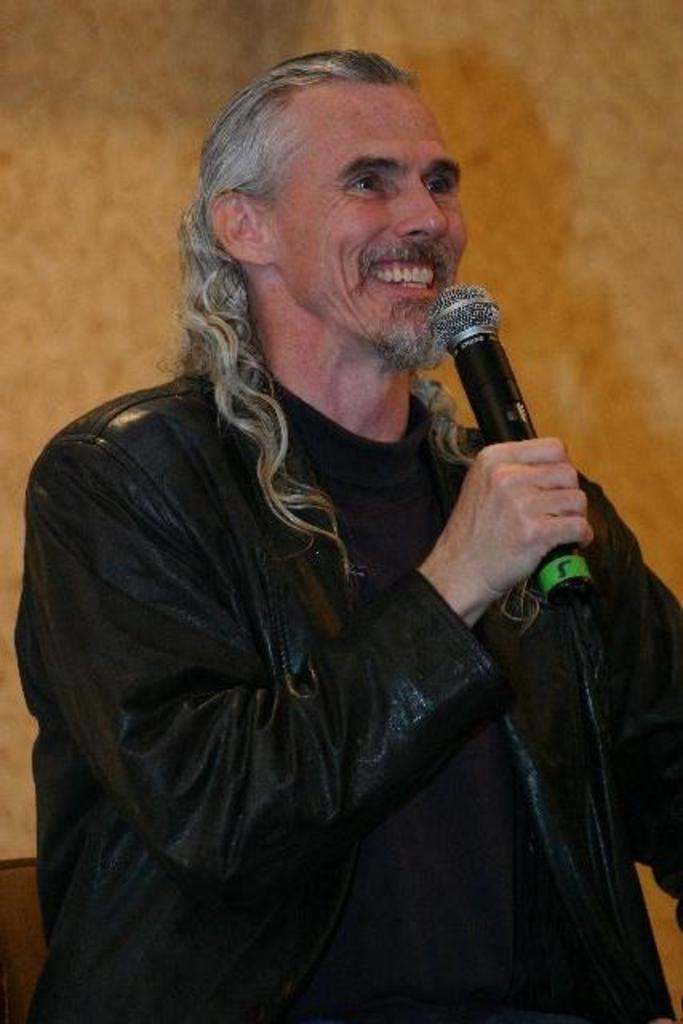Who is present in the image? There is a man in the image. What is the man wearing? The man is wearing a black dress. What is the man holding in the image? The man is holding a microphone. What color can be seen in the background of the image? There is an orange color visible in the background of the image. What type of garden can be seen in the image? There is no garden present in the image. What caption is written below the image? The provided facts do not mention any caption, so it cannot be determined from the image. 